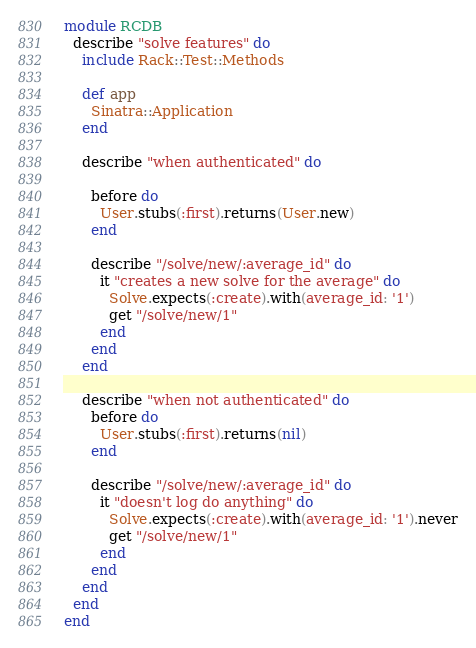Convert code to text. <code><loc_0><loc_0><loc_500><loc_500><_Ruby_>module RCDB
  describe "solve features" do
    include Rack::Test::Methods

    def app
      Sinatra::Application
    end

    describe "when authenticated" do

      before do
        User.stubs(:first).returns(User.new)
      end

      describe "/solve/new/:average_id" do
        it "creates a new solve for the average" do
          Solve.expects(:create).with(average_id: '1')
          get "/solve/new/1"
        end
      end
    end

    describe "when not authenticated" do
      before do
        User.stubs(:first).returns(nil)
      end

      describe "/solve/new/:average_id" do
        it "doesn't log do anything" do
          Solve.expects(:create).with(average_id: '1').never
          get "/solve/new/1"
        end
      end
    end
  end
end
</code> 